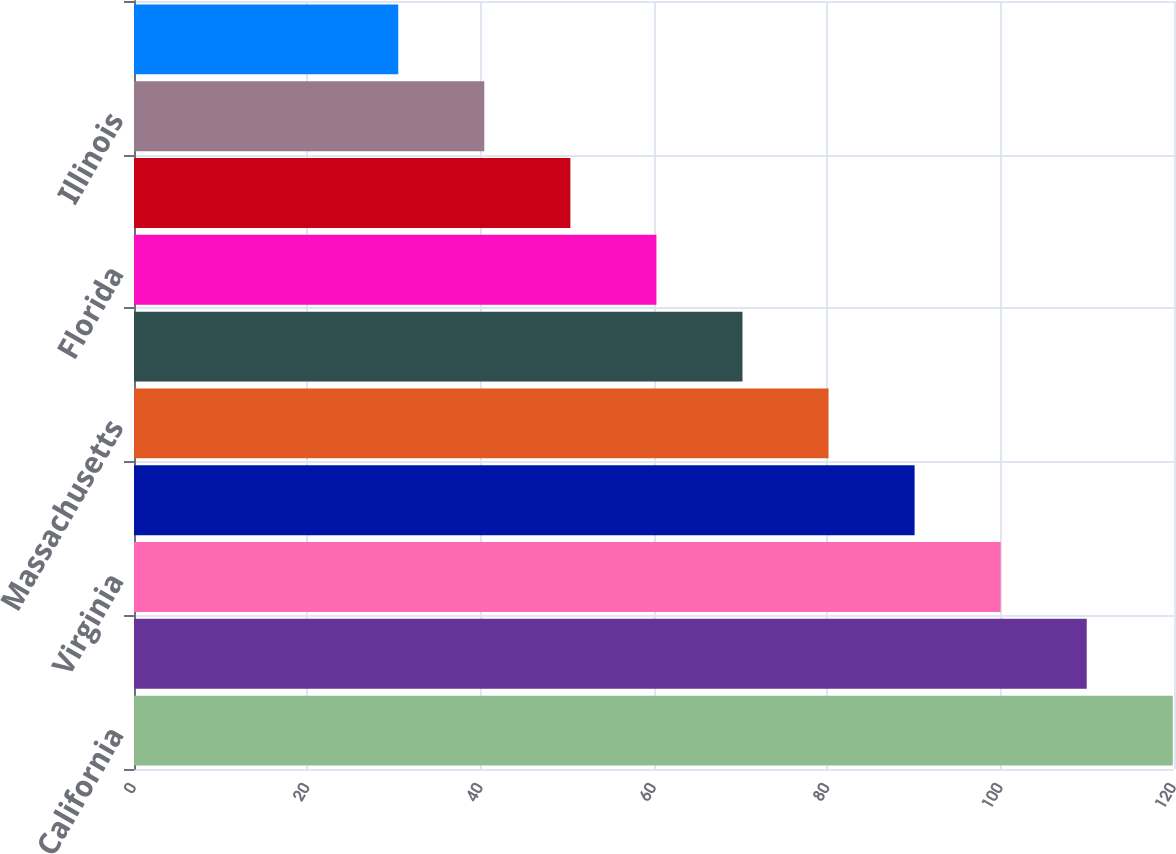<chart> <loc_0><loc_0><loc_500><loc_500><bar_chart><fcel>California<fcel>Maryland<fcel>Virginia<fcel>Pennsylvania(1)<fcel>Massachusetts<fcel>New Jersey<fcel>Florida<fcel>New York<fcel>Illinois<fcel>Connecticut<nl><fcel>119.86<fcel>109.93<fcel>100<fcel>90.07<fcel>80.14<fcel>70.21<fcel>60.28<fcel>50.35<fcel>40.42<fcel>30.49<nl></chart> 